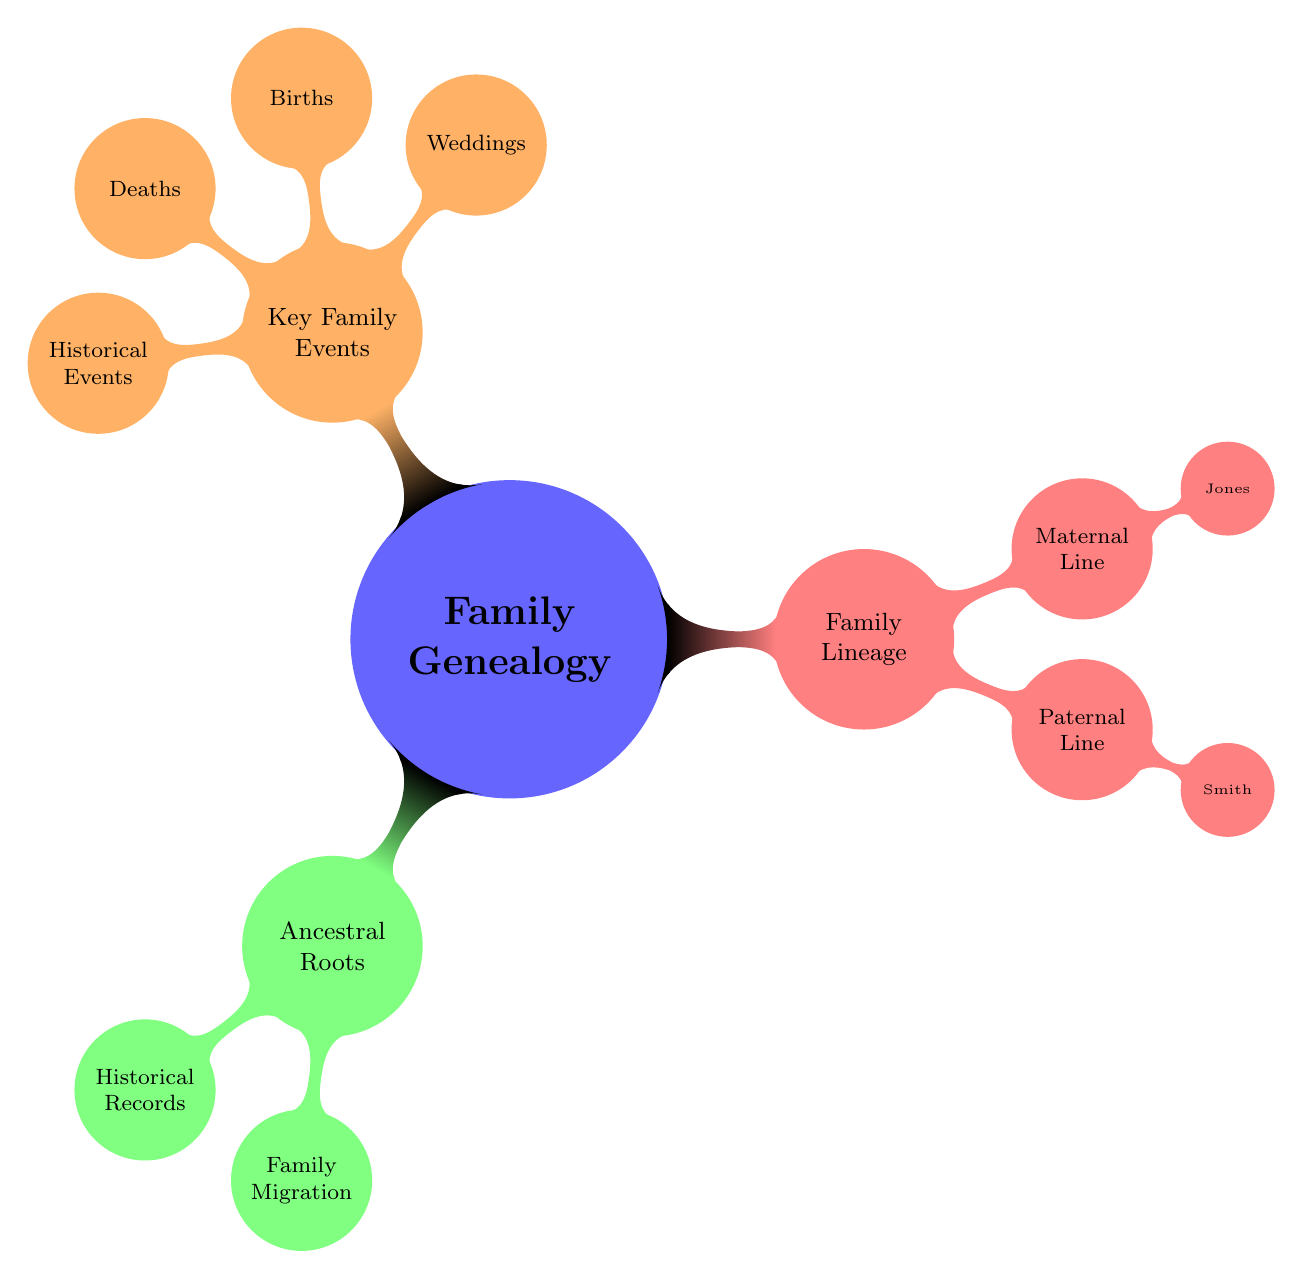What is the main topic of the mind map? The main topic is at the center of the diagram and reads "Family Genealogy: Tracing Ancestry and Key Family Events."
Answer: Family Genealogy: Tracing Ancestry and Key Family Events How many children does the "Family Lineage" node have? The "Family Lineage" node has two children: "Paternal Line" and "Maternal Line." Counting these gives a total of 2 children.
Answer: 2 What notable ancestor is listed under the Paternal Line? The "Paternal Line" node lists "John Smith (Civil War Veteran)" as a notable ancestor. This information is directly under that node.
Answer: John Smith (Civil War Veteran) Which event did Robert Jones participate in? The key family event shows that Robert Jones is noted for serving in the US Army during WWII. This links Robert Jones to that historical event.
Answer: WWII What family event occurred on June 5, 1920? The "Weddings" child node under "Key Family Events" details a wedding that occurred on June 5, 1920, between John Smith and Mary Williams. This event is clearly stated in that section.
Answer: John Smith and Mary Williams Which migration pattern is listed under "Family Migration Patterns"? The "Family Migration Patterns" node includes "Europe to America," indicating one of the migration patterns. This information can be found directly listed under that node.
Answer: Europe to America How many births are recorded in the Key Family Events? Under the "Births" child node, there are two entries: James Smith and Susan Jones, which makes a total of 2 recorded births.
Answer: 2 What surname is associated with the Maternal Line? The "Maternal Line" node explicitly states that the associated surname is "Jones," which is a straightforward reading of that section.
Answer: Jones What significant historical impact did the Great Depression have on the family? The diagram notes that one significant impact of the Great Depression was the closure of the family business, which is directly linked to the historical event.
Answer: Family Business Closure 